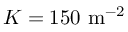Convert formula to latex. <formula><loc_0><loc_0><loc_500><loc_500>K = 1 5 0 \ m ^ { - 2 }</formula> 